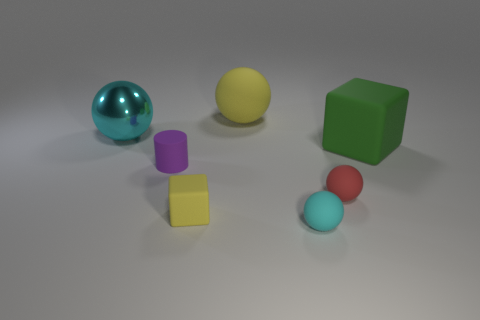Subtract all cyan shiny balls. How many balls are left? 3 Subtract all brown blocks. How many cyan spheres are left? 2 Add 1 small red matte objects. How many objects exist? 8 Subtract all green cubes. How many cubes are left? 1 Subtract 1 balls. How many balls are left? 3 Subtract all cubes. How many objects are left? 5 Subtract all red spheres. Subtract all brown cylinders. How many spheres are left? 3 Add 3 small cubes. How many small cubes exist? 4 Subtract 0 brown blocks. How many objects are left? 7 Subtract all metallic objects. Subtract all cylinders. How many objects are left? 5 